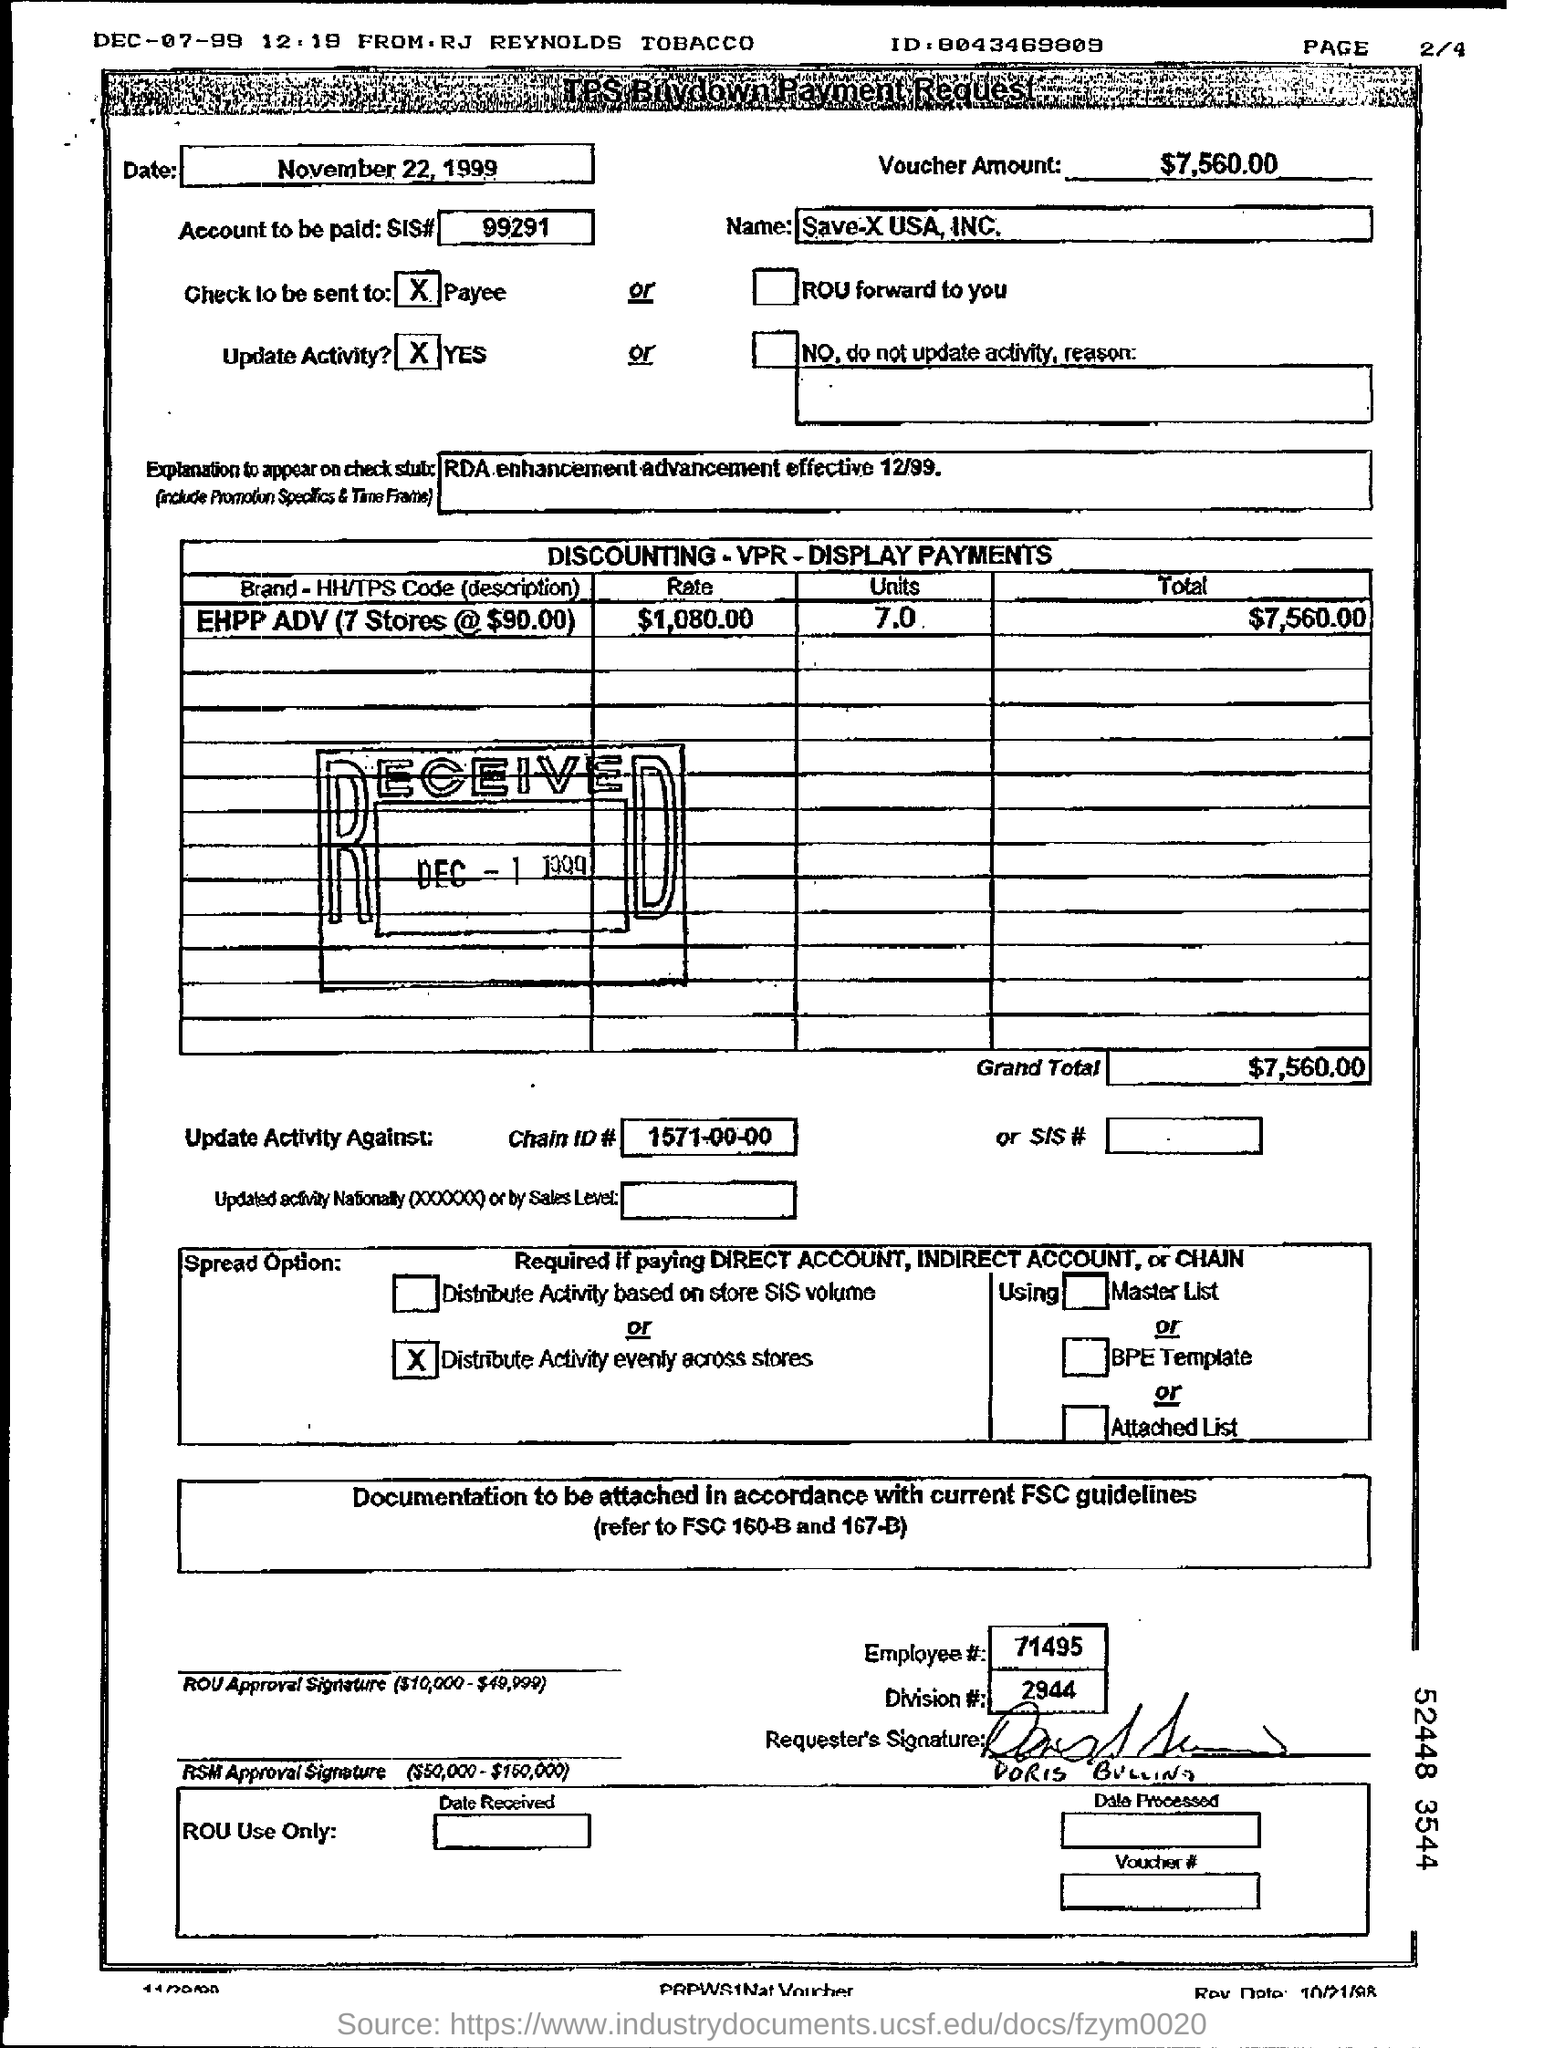What does the date 'November 22, 1999' signify in this document? The date 'November 22, 1999' on this document marks the voucher's issue or effective date for the transactions or agreements stated, such as the payment for the 'EHPP ADV' program, which is set to be effective starting December 1999. 